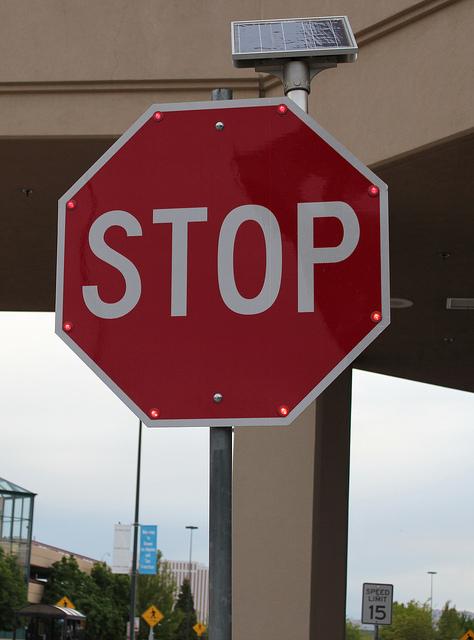Would you drive through this sign?
Be succinct. No. What does the sign say?
Answer briefly. Stop. Is the figure drawn on the stop sign smiling?
Give a very brief answer. No. Does the person at the opposite side of the intersection need to stop?
Answer briefly. Yes. What is the speed limit?
Be succinct. 15. Why are the sign's different color's?
Be succinct. Different types of signs. 